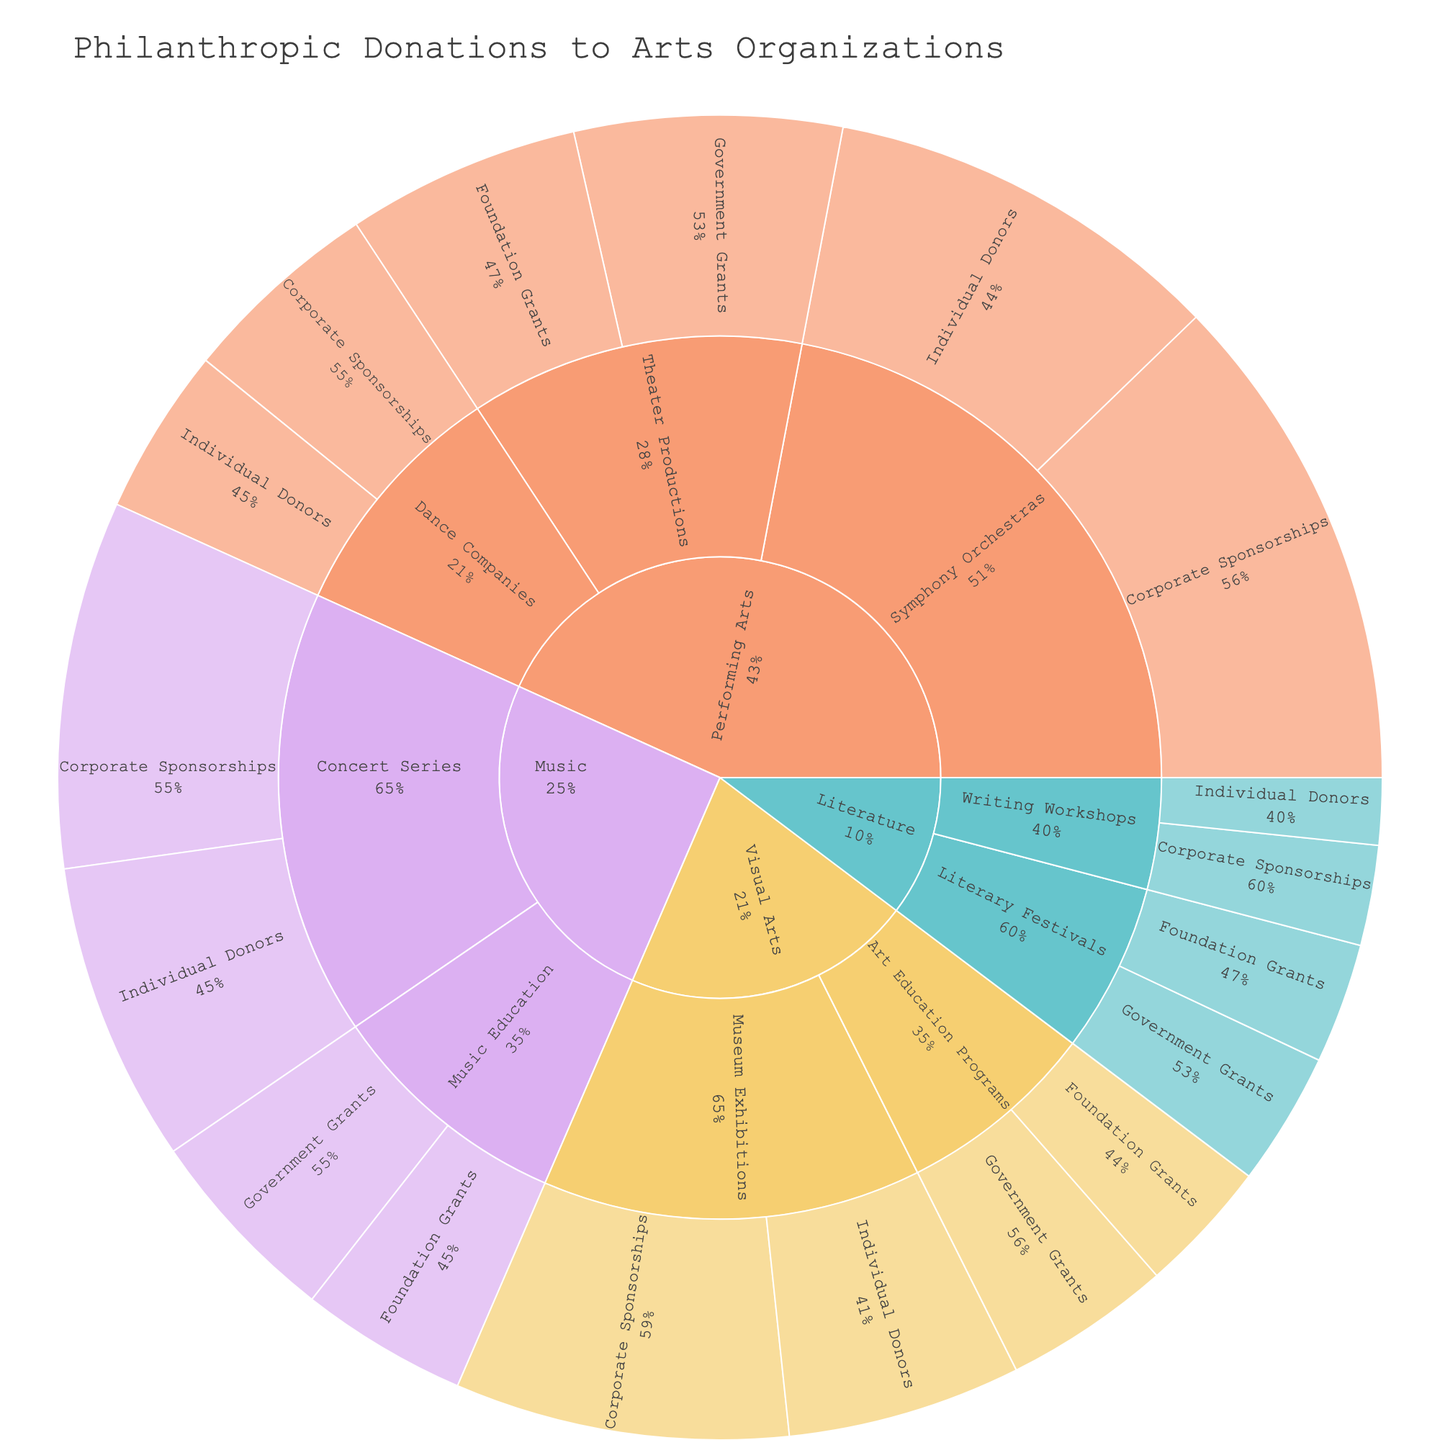How much total funding did Music receive from Corporate Sponsorships? Look for the sector 'Music', navigate to the project type 'Concert Series', and find the amount from 'Corporate Sponsorships'. Do the same for 'Music Education'. Sum those amounts: $550,000 (Concert Series) + $0 (Music Education) = $550,000.
Answer: $550,000 What's the most funded project type in the Visual Arts sector? Identify the project types under 'Visual Arts' and their respective funding amounts. Compare 'Museum Exhibitions' and 'Art Education Programs'. 'Museum Exhibitions' has higher total funding: $500,000 (Corporate Sponsorships) + $350,000 (Individual Donors) = $850,000 versus 'Art Education Programs' $250,000 (Government Grants) + $200,000 (Foundation Grants) = $450,000.
Answer: Museum Exhibitions What is the total amount of foundation grants given across all sectors? Sum all amounts categorized under 'Foundation Grants' across different sectors and project types: $200,000 (Visual Arts, Art Education Programs) + $350,000 (Performing Arts, Theater Productions) + $250,000 (Music, Music Education) + $180,000 (Literature, Literary Festivals) = $980,000.
Answer: $980,000 Which sector received the highest total donations? Sum all the donations amounts for each sector and compare:
- Visual Arts: $500,000 + $350,000 + $250,000 + $200,000 = $1,300,000
- Performing Arts: $750,000 + $600,000 + $400,000 + $350,000 + $300,000 + $250,000 = $2,650,000
- Music: $550,000 + $450,000 + $300,000 + $250,000 = $1,550,000
- Literature: $150,000 + $100,000 + $200,000 + $180,000 = $630,000
Performing Arts has the highest total donations.
Answer: Performing Arts How do the total donations from Individual Donors compare between Performing Arts and Literature? Sum the amounts from 'Individual Donors' for both sectors and compare:
- Performing Arts: $600,000 (Symphony Orchestras) + $250,000 (Dance Companies) = $850,000
- Literature: $100,000 (Writing Workshops)
Comparing the total from Performing Arts ($850,000) to Literature ($100,000), Performing Arts has more.
Answer: Performing Arts Which funding source provided the highest total donations to Performing Arts? Identify and sum donations from each funding source under 'Performing Arts' sector:
- Corporate Sponsorships: $750,000 (Symphony Orchestras) + $300,000 (Dance Companies) = $1,050,000
- Individual Donors: $600,000 (Symphony Orchestras) + $250,000 (Dance Companies) = $850,000
- Government Grants: $400,000 (Theater Productions)
- Foundation Grants: $350,000 (Theater Productions)
Corporate Sponsorships provided the highest total donations.
Answer: Corporate Sponsorships What percentage of the total donations does the Literature sector contribute? Calculate the total donations for all sectors and the Literature sector:
- Total donations across all sectors: $1,300,000 (Visual Arts) + $2,650,000 (Performing Arts) + $1,550,000 (Music) + $630,000 (Literature) = $6,130,000
- Percentage contribution by Literature: ($630,000 / $6,130,000) * 100 ≈ 10.28%.
Answer: 10.28% What is the least funded project type under Music? Compare the donations for project types under 'Music':
- Concert Series: $550,000 (Corporate Sponsorships) + $450,000 (Individual Donors) = $1,000,000
- Music Education: $300,000 (Government Grants) + $250,000 (Foundation Grants) = $550,000
Music Education is the least funded.
Answer: Music Education Which project type in Performing Arts has the highest individual donor contribution? Investigate individual donors' contributions across various project types in 'Performing Arts':
- Symphony Orchestras: $600,000
- Theater Productions: $0
- Dance Companies: $250,000
Symphony Orchestras have the highest individual donor contribution.
Answer: Symphony Orchestras 